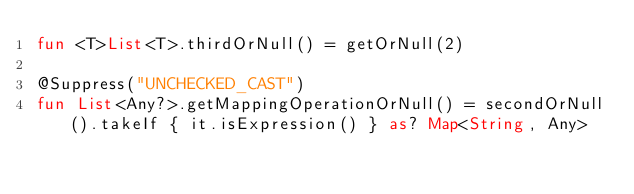<code> <loc_0><loc_0><loc_500><loc_500><_Kotlin_>fun <T>List<T>.thirdOrNull() = getOrNull(2)

@Suppress("UNCHECKED_CAST")
fun List<Any?>.getMappingOperationOrNull() = secondOrNull().takeIf { it.isExpression() } as? Map<String, Any>
</code> 